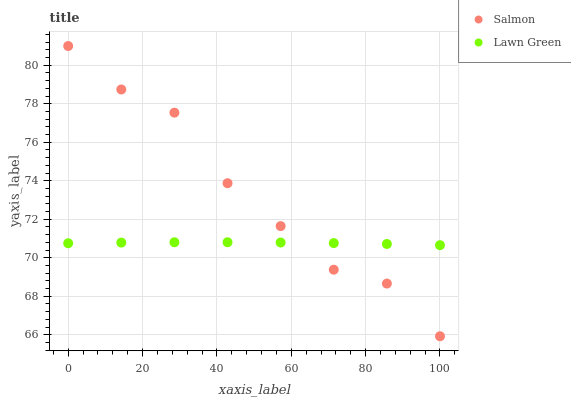Does Lawn Green have the minimum area under the curve?
Answer yes or no. Yes. Does Salmon have the maximum area under the curve?
Answer yes or no. Yes. Does Salmon have the minimum area under the curve?
Answer yes or no. No. Is Lawn Green the smoothest?
Answer yes or no. Yes. Is Salmon the roughest?
Answer yes or no. Yes. Is Salmon the smoothest?
Answer yes or no. No. Does Salmon have the lowest value?
Answer yes or no. Yes. Does Salmon have the highest value?
Answer yes or no. Yes. Does Salmon intersect Lawn Green?
Answer yes or no. Yes. Is Salmon less than Lawn Green?
Answer yes or no. No. Is Salmon greater than Lawn Green?
Answer yes or no. No. 